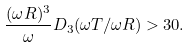<formula> <loc_0><loc_0><loc_500><loc_500>\frac { ( \omega R ) ^ { 3 } } { \omega } D _ { 3 } ( \omega T / \omega R ) > 3 0 .</formula> 